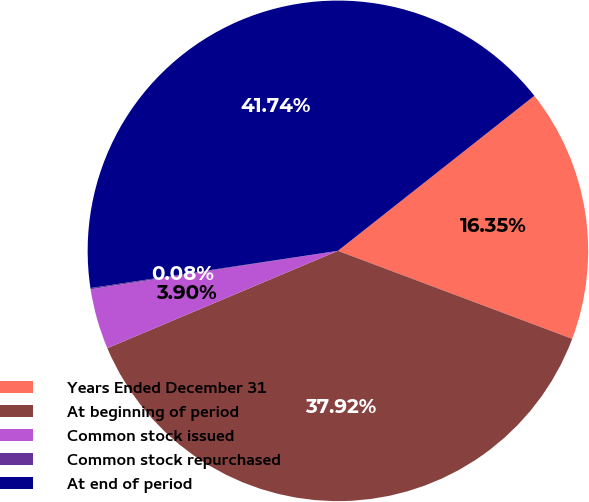Convert chart. <chart><loc_0><loc_0><loc_500><loc_500><pie_chart><fcel>Years Ended December 31<fcel>At beginning of period<fcel>Common stock issued<fcel>Common stock repurchased<fcel>At end of period<nl><fcel>16.35%<fcel>37.92%<fcel>3.9%<fcel>0.08%<fcel>41.74%<nl></chart> 